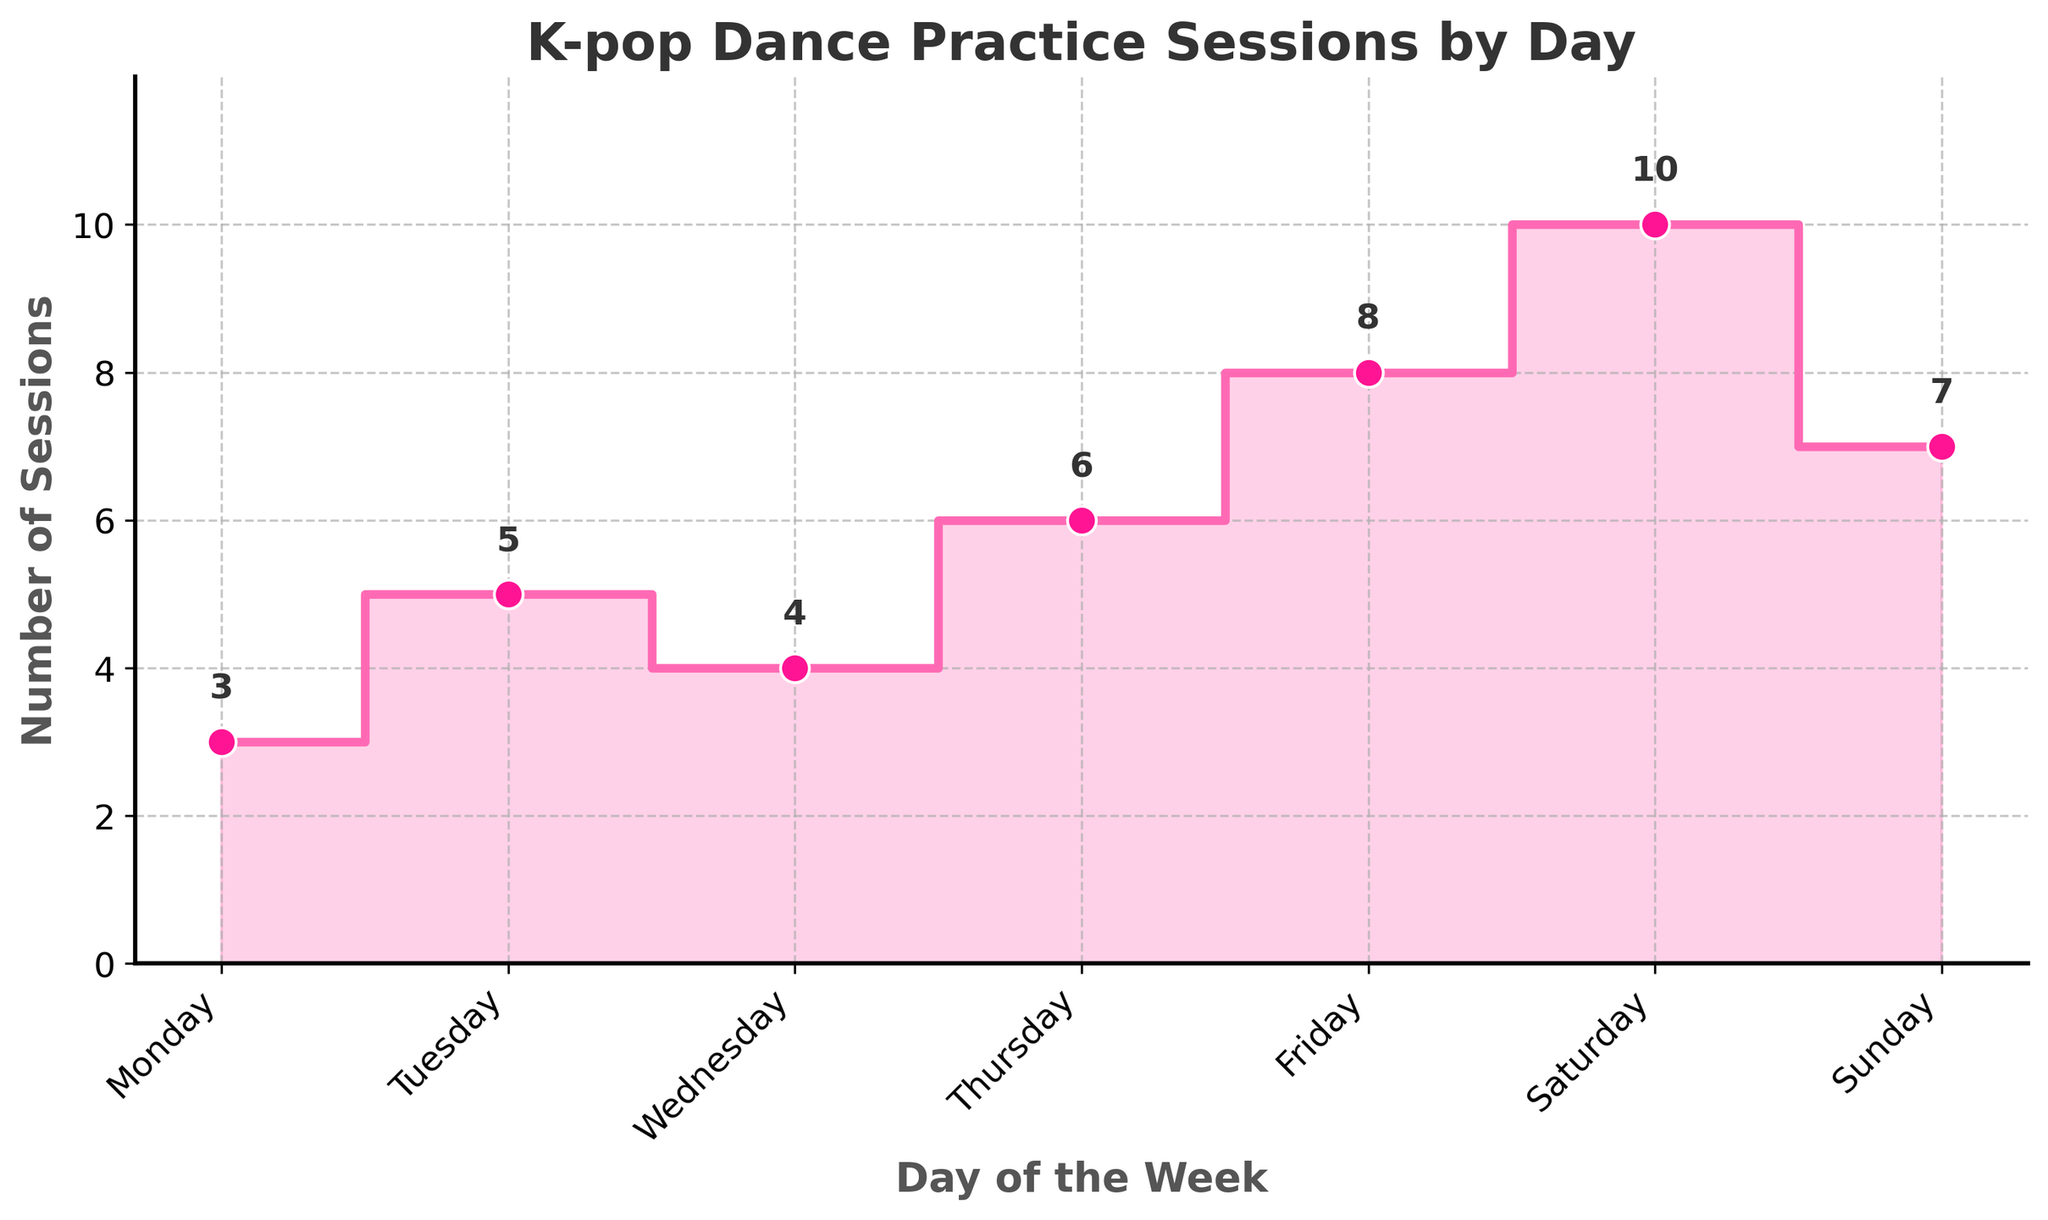What's the title of the figure? The title of the figure is displayed at the top, which provides the main topic of the visualization.
Answer: "K-pop Dance Practice Sessions by Day" What does the x-axis represent in the plot? The x-axis represents the days of the week, as seen from the labels along the horizontal axis.
Answer: Days of the week What is the total number of sessions practiced on weekends (Saturday and Sunday)? Sum the session counts for Saturday and Sunday by adding 10 (Saturday) and 7 (Sunday).
Answer: 17 Which day of the week has the highest number of dance practice sessions? By examining the heights of the steps, Saturday has the maximum height with a session count of 10.
Answer: Saturday How many more practice sessions are there on Friday compared to Wednesday? The step height on Friday is 8 and on Wednesday is 4. Subtract the two values: 8 - 4 = 4.
Answer: 4 more sessions What is the average number of practice sessions per day? First, sum all the session counts: 3 + 5 + 4 + 6 + 8 + 10 + 7 = 43. Then, divide by the number of days (7): 43 / 7 = 6.14.
Answer: 6.14 Does the plot show a trend in the number of practice sessions throughout the week? Observing the plot, there's a general upward trend from the start of the week (Monday) to its end, peaking on Saturday with a slight drop on Sunday.
Answer: Yes, upward trend What’s the difference in the number of sessions between the day with the most and the day with the least sessions? The highest session count is 10 (Saturday) and the lowest is 3 (Monday). The difference is 10 - 3 = 7.
Answer: 7 sessions If you want to increase the consistency of practice sessions throughout the week, which days should you focus on increasing? You should aim to increase sessions on days with lower counts to match the higher counts, specifically Monday (3) and Wednesday (4).
Answer: Monday and Wednesday What is the total number of practice sessions from Monday to Thursday? Sum the session counts from Monday to Thursday: 3 + 5 + 4 + 6 = 18.
Answer: 18 